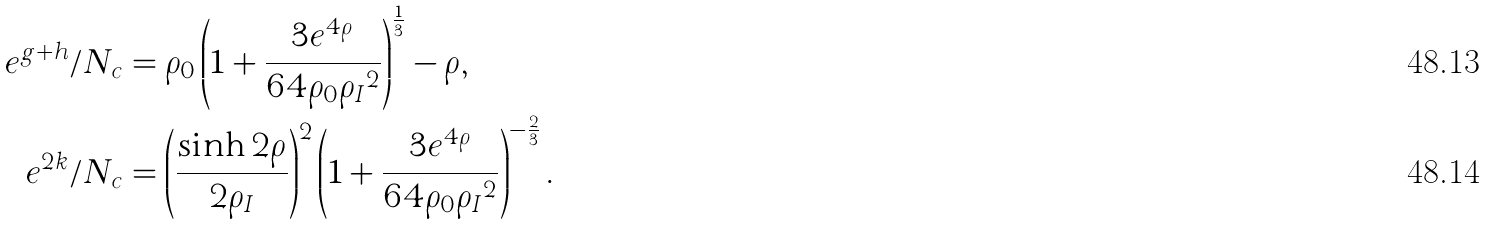<formula> <loc_0><loc_0><loc_500><loc_500>e ^ { g + h } / N _ { c } & = \rho _ { 0 } \left ( 1 + \frac { 3 e ^ { 4 \rho } } { 6 4 \rho _ { 0 } { \rho _ { I } } ^ { 2 } } \right ) ^ { \frac { 1 } { 3 } } - \rho , \\ e ^ { 2 k } / N _ { c } & = \left ( \frac { \sinh { 2 \rho } } { 2 \rho _ { I } } \right ) ^ { 2 } \left ( 1 + \frac { 3 e ^ { 4 \rho } } { 6 4 \rho _ { 0 } { \rho _ { I } } ^ { 2 } } \right ) ^ { - \frac { 2 } { 3 } } .</formula> 